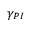Convert formula to latex. <formula><loc_0><loc_0><loc_500><loc_500>\gamma _ { P I }</formula> 